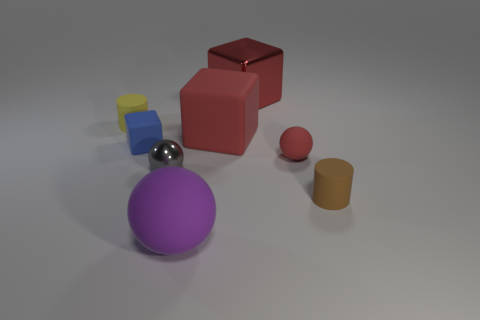What is the size of the rubber cube that is the same color as the large metallic object?
Your response must be concise. Large. There is a red thing that is behind the tiny red sphere and in front of the tiny yellow rubber object; how big is it?
Your answer should be compact. Large. There is a small brown object; is it the same shape as the big red thing behind the yellow cylinder?
Provide a succinct answer. No. How many things are either objects in front of the tiny brown rubber thing or tiny blue rubber blocks?
Give a very brief answer. 2. Is the large sphere made of the same material as the tiny gray sphere in front of the tiny blue matte thing?
Keep it short and to the point. No. What shape is the thing that is in front of the matte cylinder in front of the blue cube?
Offer a very short reply. Sphere. Do the big sphere and the metallic object that is left of the metallic cube have the same color?
Offer a terse response. No. Is there anything else that is made of the same material as the tiny brown cylinder?
Ensure brevity in your answer.  Yes. What is the shape of the tiny blue thing?
Your response must be concise. Cube. There is a matte block that is to the left of the gray thing to the left of the large purple ball; what size is it?
Keep it short and to the point. Small. 